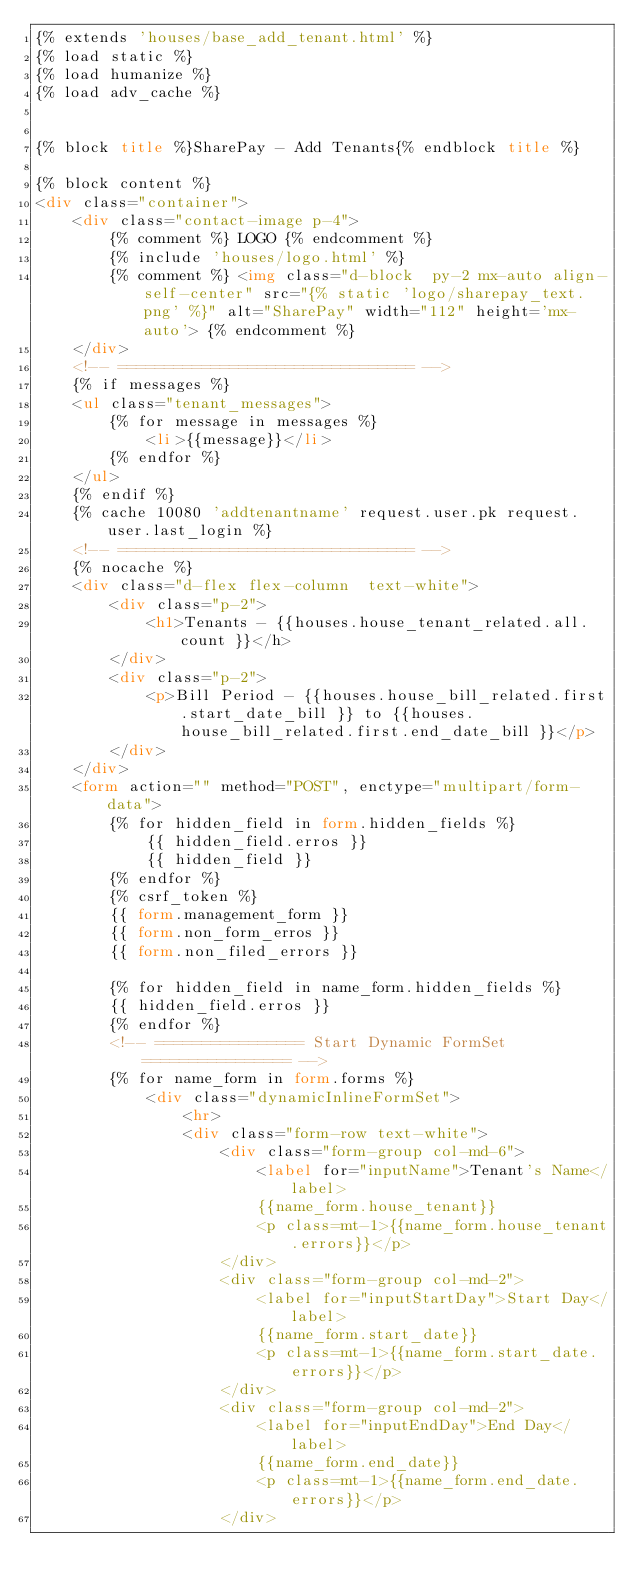Convert code to text. <code><loc_0><loc_0><loc_500><loc_500><_HTML_>{% extends 'houses/base_add_tenant.html' %}
{% load static %}
{% load humanize %}
{% load adv_cache %}


{% block title %}SharePay - Add Tenants{% endblock title %}

{% block content %}
<div class="container">
    <div class="contact-image p-4">
        {% comment %} LOGO {% endcomment %}
        {% include 'houses/logo.html' %}
        {% comment %} <img class="d-block  py-2 mx-auto align-self-center" src="{% static 'logo/sharepay_text.png' %}" alt="SharePay" width="112" height='mx-auto'> {% endcomment %}
    </div>
    <!-- ================================ -->
    {% if messages %}
    <ul class="tenant_messages">
        {% for message in messages %}
            <li>{{message}}</li>
        {% endfor %}
    </ul>
    {% endif %}
    {% cache 10080 'addtenantname' request.user.pk request.user.last_login %}
    <!-- ================================ -->
    {% nocache %}
    <div class="d-flex flex-column  text-white">
        <div class="p-2">
            <h1>Tenants - {{houses.house_tenant_related.all.count }}</h>
        </div>
        <div class="p-2">
            <p>Bill Period - {{houses.house_bill_related.first.start_date_bill }} to {{houses.house_bill_related.first.end_date_bill }}</p>
        </div>
    </div>
    <form action="" method="POST", enctype="multipart/form-data">
        {% for hidden_field in form.hidden_fields %}
            {{ hidden_field.erros }}
            {{ hidden_field }}
        {% endfor %}
        {% csrf_token %}
        {{ form.management_form }}
        {{ form.non_form_erros }}
        {{ form.non_filed_errors }}
        
        {% for hidden_field in name_form.hidden_fields %}
        {{ hidden_field.erros }}
        {% endfor %}
        <!-- ================ Start Dynamic FormSet ================ -->
        {% for name_form in form.forms %}
            <div class="dynamicInlineFormSet">
                <hr>
                <div class="form-row text-white">
                    <div class="form-group col-md-6">
                        <label for="inputName">Tenant's Name</label>
                        {{name_form.house_tenant}}
                        <p class=mt-1>{{name_form.house_tenant.errors}}</p>
                    </div>
                    <div class="form-group col-md-2">
                        <label for="inputStartDay">Start Day</label>
                        {{name_form.start_date}}
                        <p class=mt-1>{{name_form.start_date.errors}}</p>
                    </div>
                    <div class="form-group col-md-2">
                        <label for="inputEndDay">End Day</label>
                        {{name_form.end_date}}
                        <p class=mt-1>{{name_form.end_date.errors}}</p>
                    </div></code> 